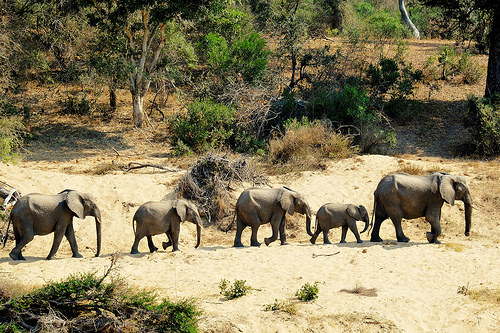<image>
Is the elephant behind the elephant? Yes. From this viewpoint, the elephant is positioned behind the elephant, with the elephant partially or fully occluding the elephant. Is there a elephant above the sand? No. The elephant is not positioned above the sand. The vertical arrangement shows a different relationship. 